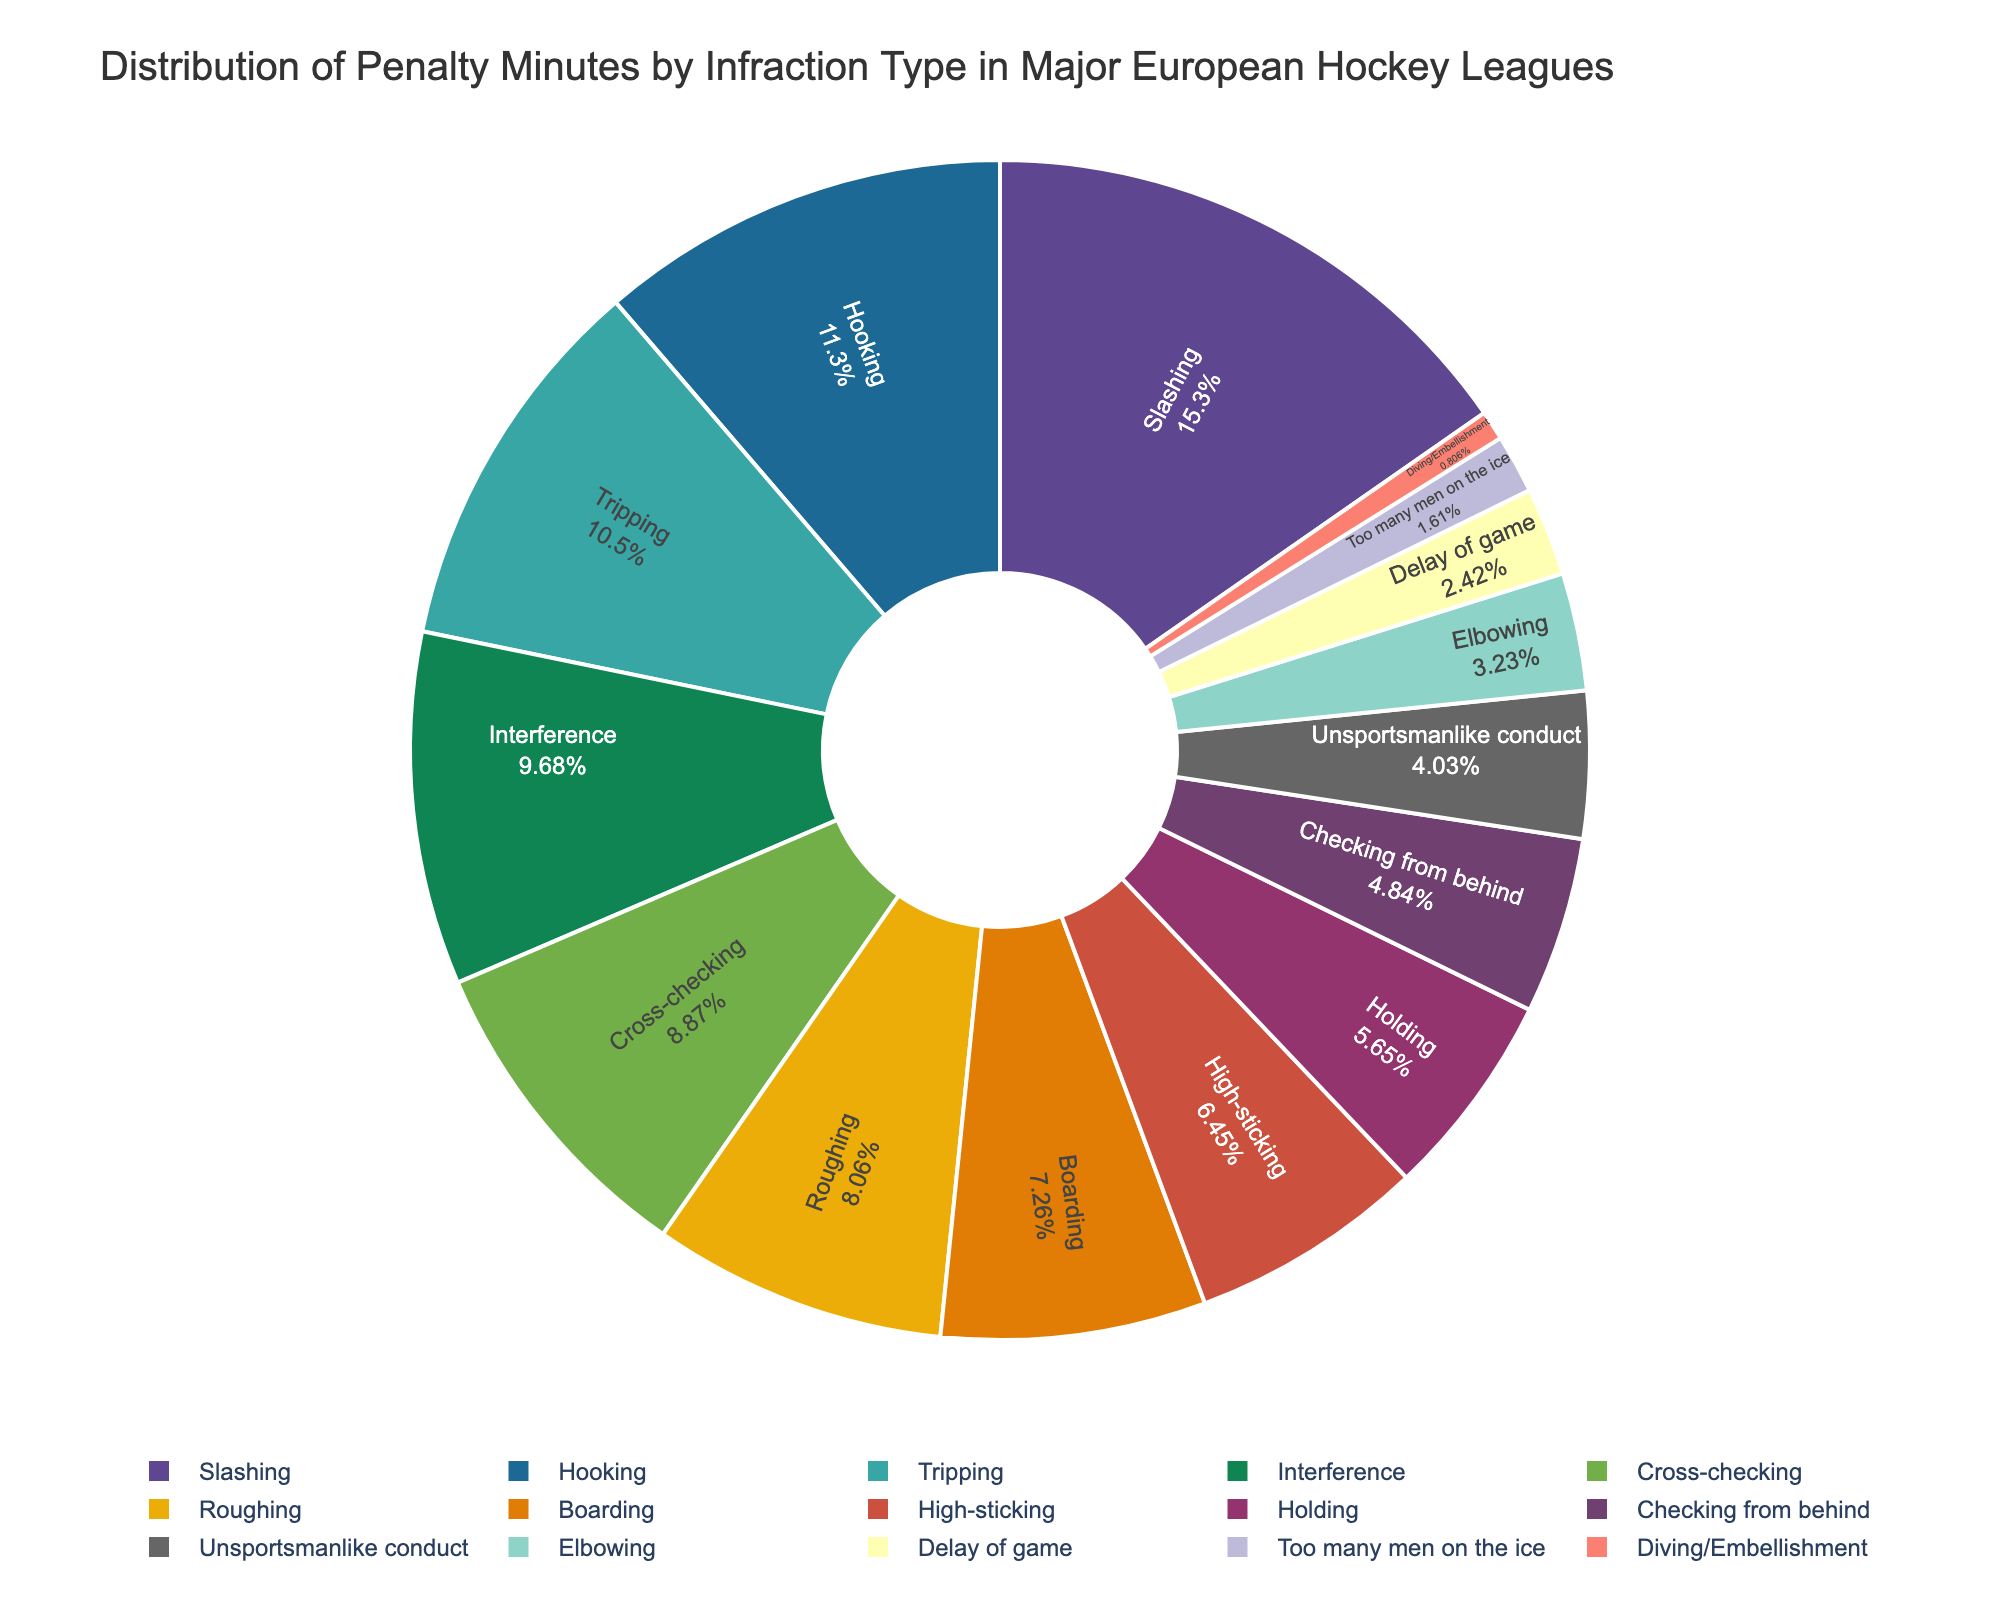What infraction type accounts for the highest percentage of penalty minutes? By looking at the large segments and labels inside the pie chart, the infraction with the highest percentage of the pie is identified.
Answer: Slashing What is the combined total percentage of the three infractions with the least penalty minutes? Identify the three smallest segments, sum their percentages to get the combined total. The infractions with the least penalty minutes appear in smaller slices of the pie chart.
Answer: Too Many Men on the Ice, Diving/Embellishment, Elbowing Which infraction type has more penalty minutes, Hooking or Interference? Compare the sizes of the two segments associated with these infractions. Hooking's segment appears larger than Interference's.
Answer: Hooking Are there more penalty minutes for Roughing or Boarding? Roughing's segment and Boarding's segment are compared. The Roughing segment is larger than the Boarding segment.
Answer: Roughing Adding the penalty minutes of Cross-checking, High-sticking, and Holding, is this total greater than Slashing? Sum the penalty minutes for Cross-checking (165), High-sticking (120), and Holding (105). Check if this sum is greater than Slashing's penalty minutes (285). The total is 390, which is greater than 285.
Answer: Yes Does Interference account for a greater percentage of penalty minutes than Tripping? Compare the percentage size of the Interference segment with that of the Tripping segment. The two are very close, but Tripping is marginally less.
Answer: Yes If you grouped Delay of Game, Too Many Men on the Ice, and Diving/Embellishment together, would their combined percentage still be less than Elbowing? Sum their percentages and compare this with the percentage given to Elbowing. The combined percentage would be more than Elbowing.
Answer: No What is the visual characteristic that helps distinguish between infraction types? The segments are differentiated by distinct colors and the designated labels inside each segment that mention the infraction types and percentages.
Answer: Color and labels If Boarding and High-sticking penalties were combined, would their sum be higher than Hooking? Sum the penalty minutes for Boarding (135) and High-sticking (120) to see if it exceeds Hooking's penalty minutes (210). The sum of Boarding and High-sticking is 255, which is more than Hooking.
Answer: Yes 